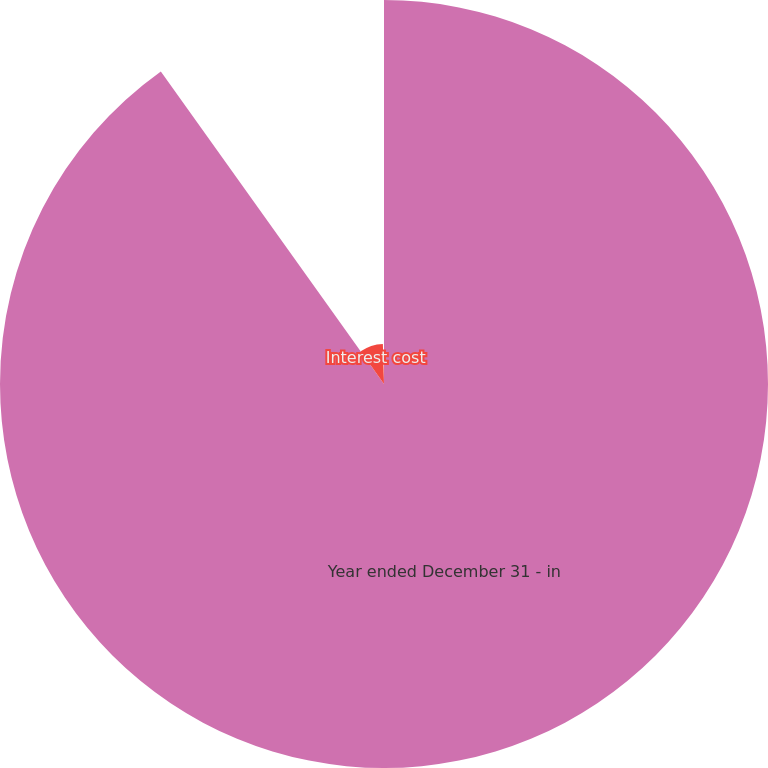Convert chart. <chart><loc_0><loc_0><loc_500><loc_500><pie_chart><fcel>Year ended December 31 - in<fcel>Interest cost<fcel>Net periodic cost<nl><fcel>90.13%<fcel>9.42%<fcel>0.45%<nl></chart> 